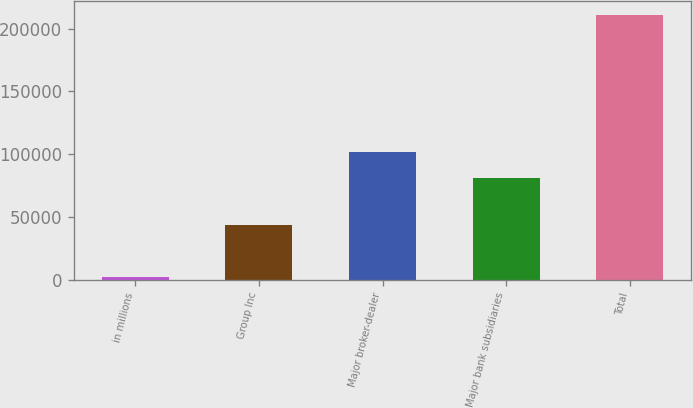Convert chart. <chart><loc_0><loc_0><loc_500><loc_500><bar_chart><fcel>in millions<fcel>Group Inc<fcel>Major broker-dealer<fcel>Major bank subsidiaries<fcel>Total<nl><fcel>2016<fcel>43638<fcel>101855<fcel>80946<fcel>211103<nl></chart> 